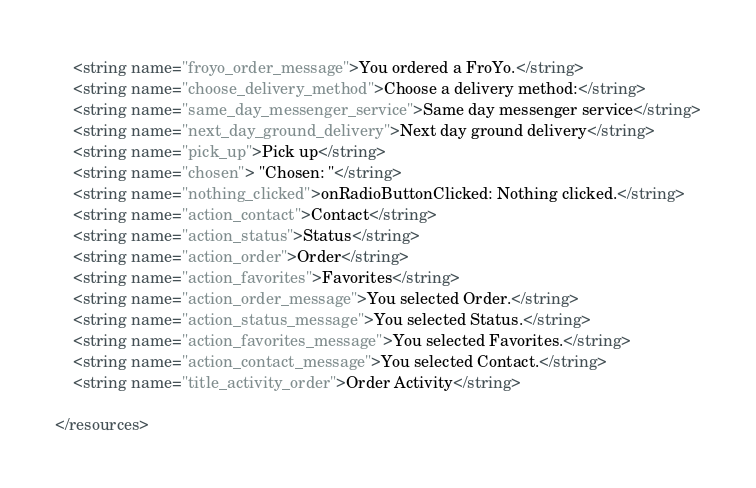<code> <loc_0><loc_0><loc_500><loc_500><_XML_>    <string name="froyo_order_message">You ordered a FroYo.</string>
    <string name="choose_delivery_method">Choose a delivery method:</string>
    <string name="same_day_messenger_service">Same day messenger service</string>
    <string name="next_day_ground_delivery">Next day ground delivery</string>
    <string name="pick_up">Pick up</string>
    <string name="chosen"> "Chosen: "</string>
    <string name="nothing_clicked">onRadioButtonClicked: Nothing clicked.</string>
    <string name="action_contact">Contact</string>
    <string name="action_status">Status</string>
    <string name="action_order">Order</string>
    <string name="action_favorites">Favorites</string>
    <string name="action_order_message">You selected Order.</string>
    <string name="action_status_message">You selected Status.</string>
    <string name="action_favorites_message">You selected Favorites.</string>
    <string name="action_contact_message">You selected Contact.</string>
    <string name="title_activity_order">Order Activity</string>

</resources>
</code> 